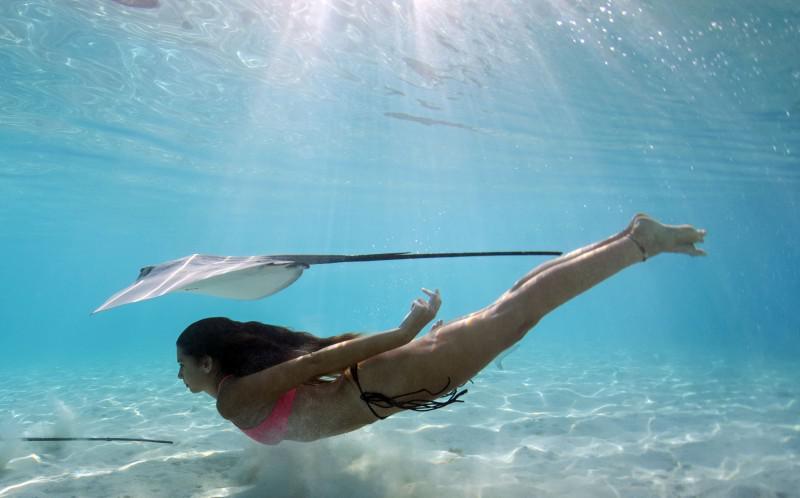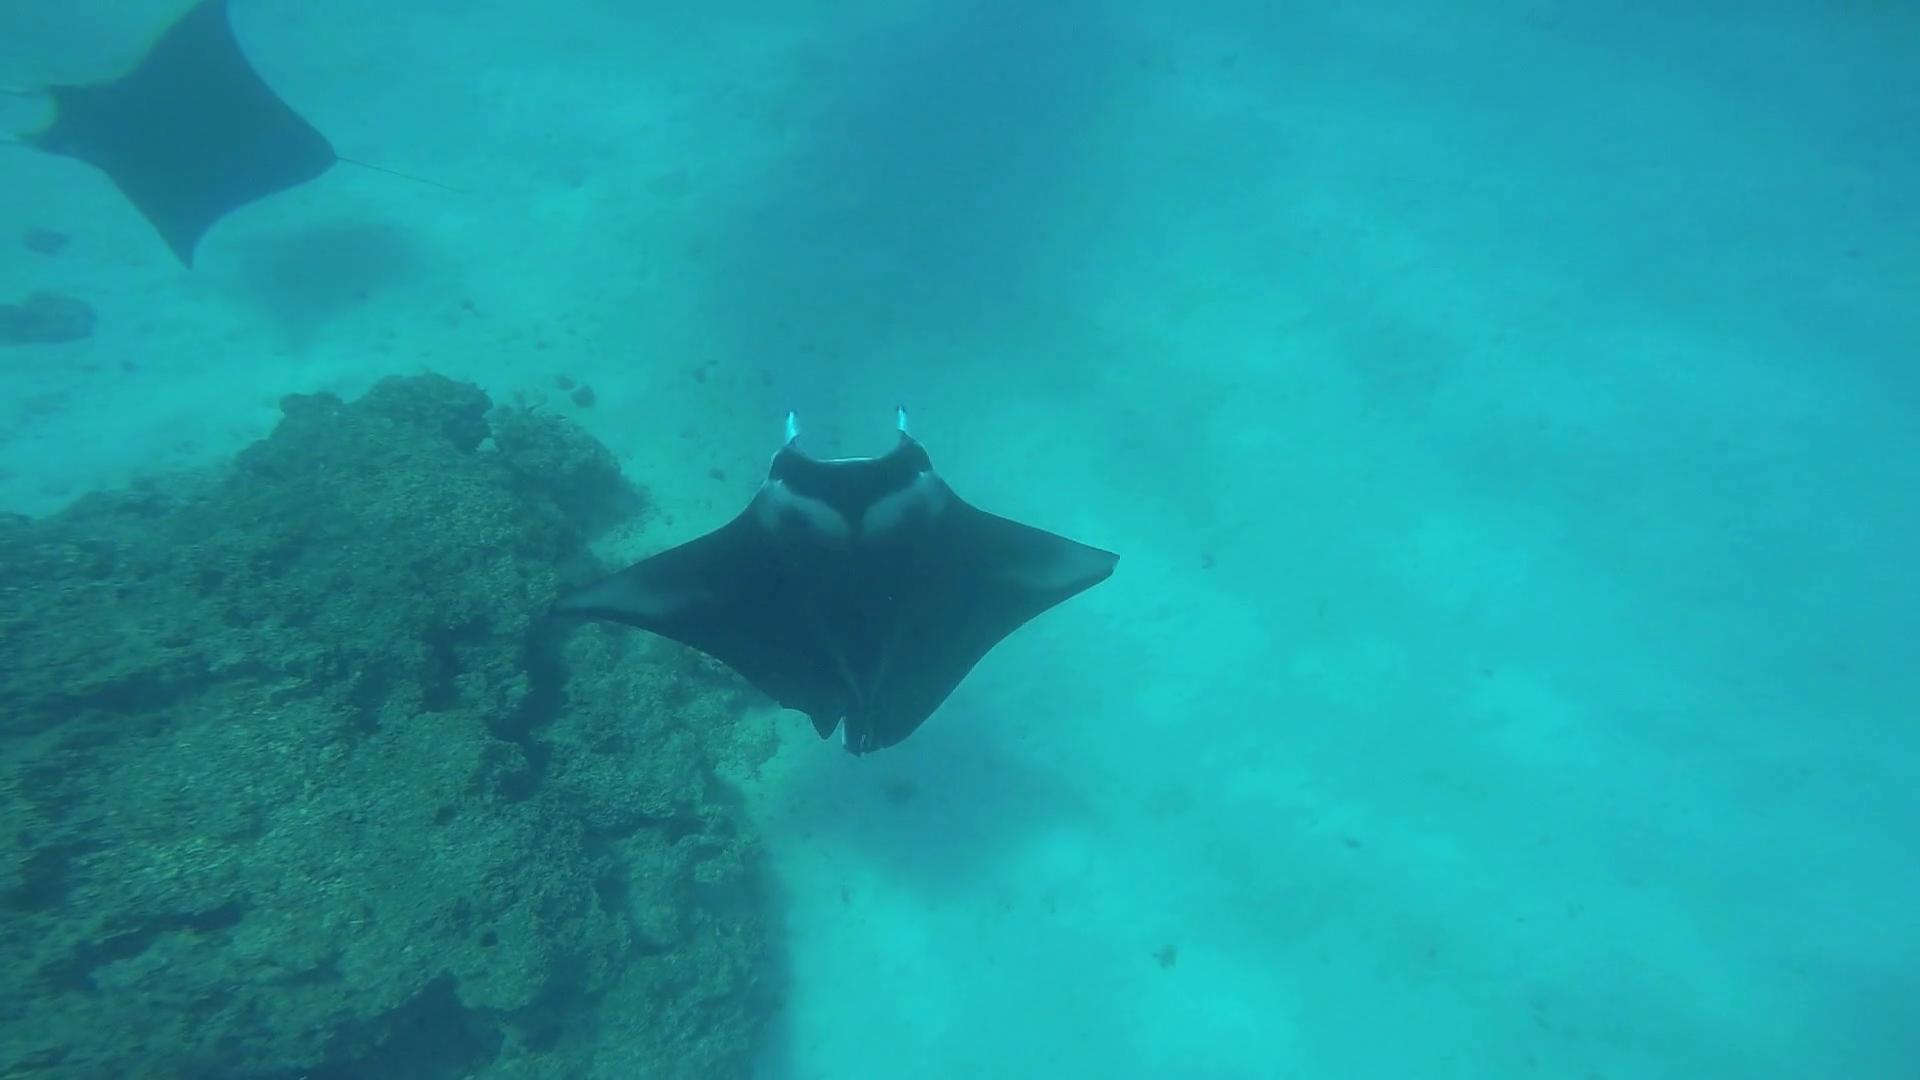The first image is the image on the left, the second image is the image on the right. For the images displayed, is the sentence "There are less than five fish visible." factually correct? Answer yes or no. Yes. 